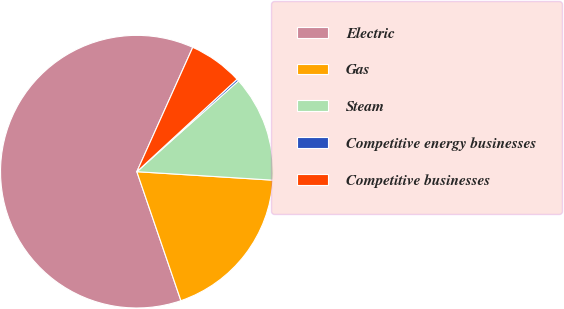<chart> <loc_0><loc_0><loc_500><loc_500><pie_chart><fcel>Electric<fcel>Gas<fcel>Steam<fcel>Competitive energy businesses<fcel>Competitive businesses<nl><fcel>61.96%<fcel>18.77%<fcel>12.6%<fcel>0.25%<fcel>6.42%<nl></chart> 